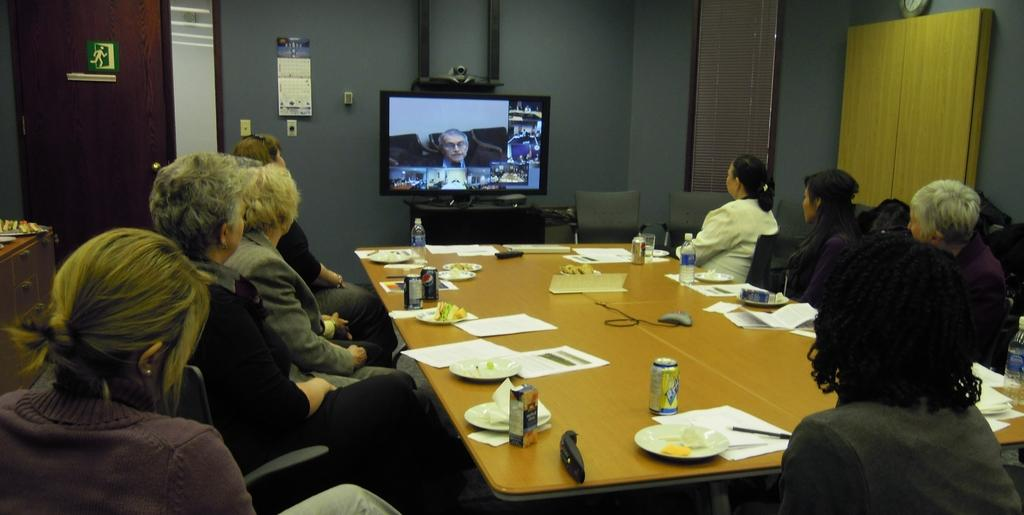What are the people in the image doing? The people in the image are sitting on chairs. What objects can be seen on the table in the image? There are papers, cans, and plates on the table in the image. What is located in the background of the image? There is a television in the background of the image. What type of peace symbol can be seen on the table in the image? There is no peace symbol present on the table in the image. What shape is the square that the people are sitting on in the image? There is no square mentioned in the image, and the people are sitting on chairs, not a square. 